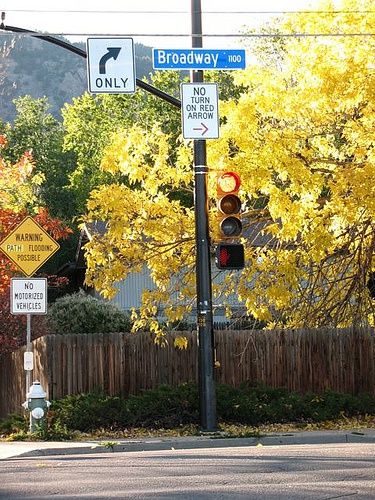Describe the objects in this image and their specific colors. I can see traffic light in white, black, maroon, olive, and khaki tones and fire hydrant in white, lightgray, gray, black, and darkgray tones in this image. 